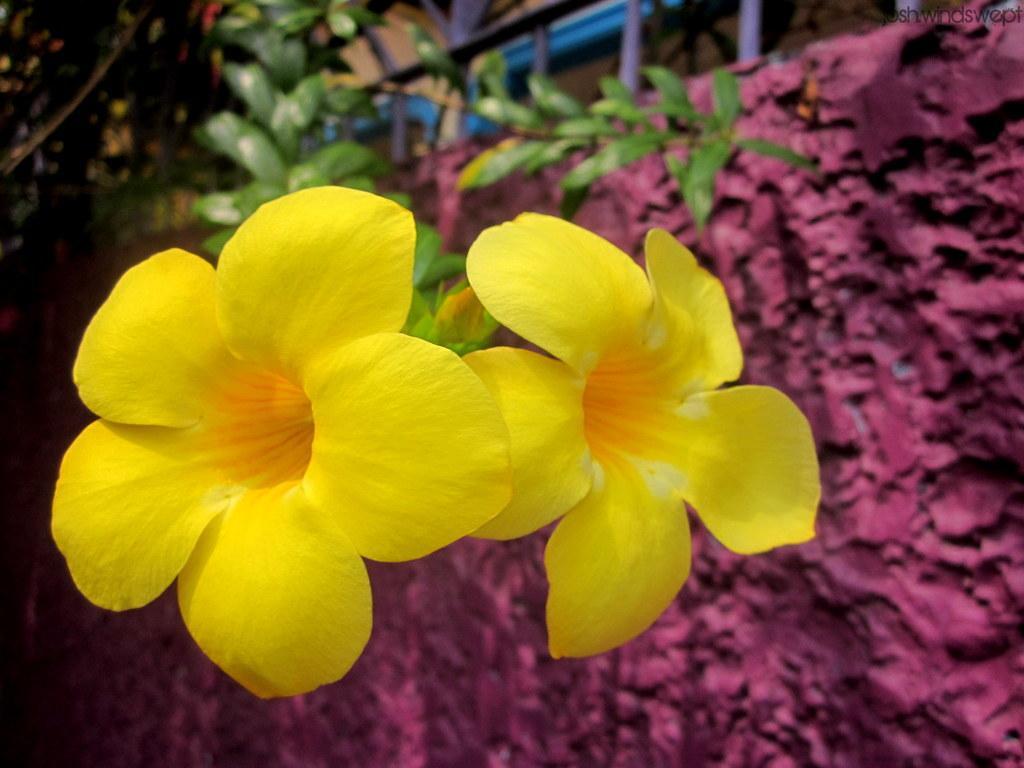Could you give a brief overview of what you see in this image? This image consists of two flowers in yellow color. On the right, we can see a wall in pink color. In the background, there is a plant. 